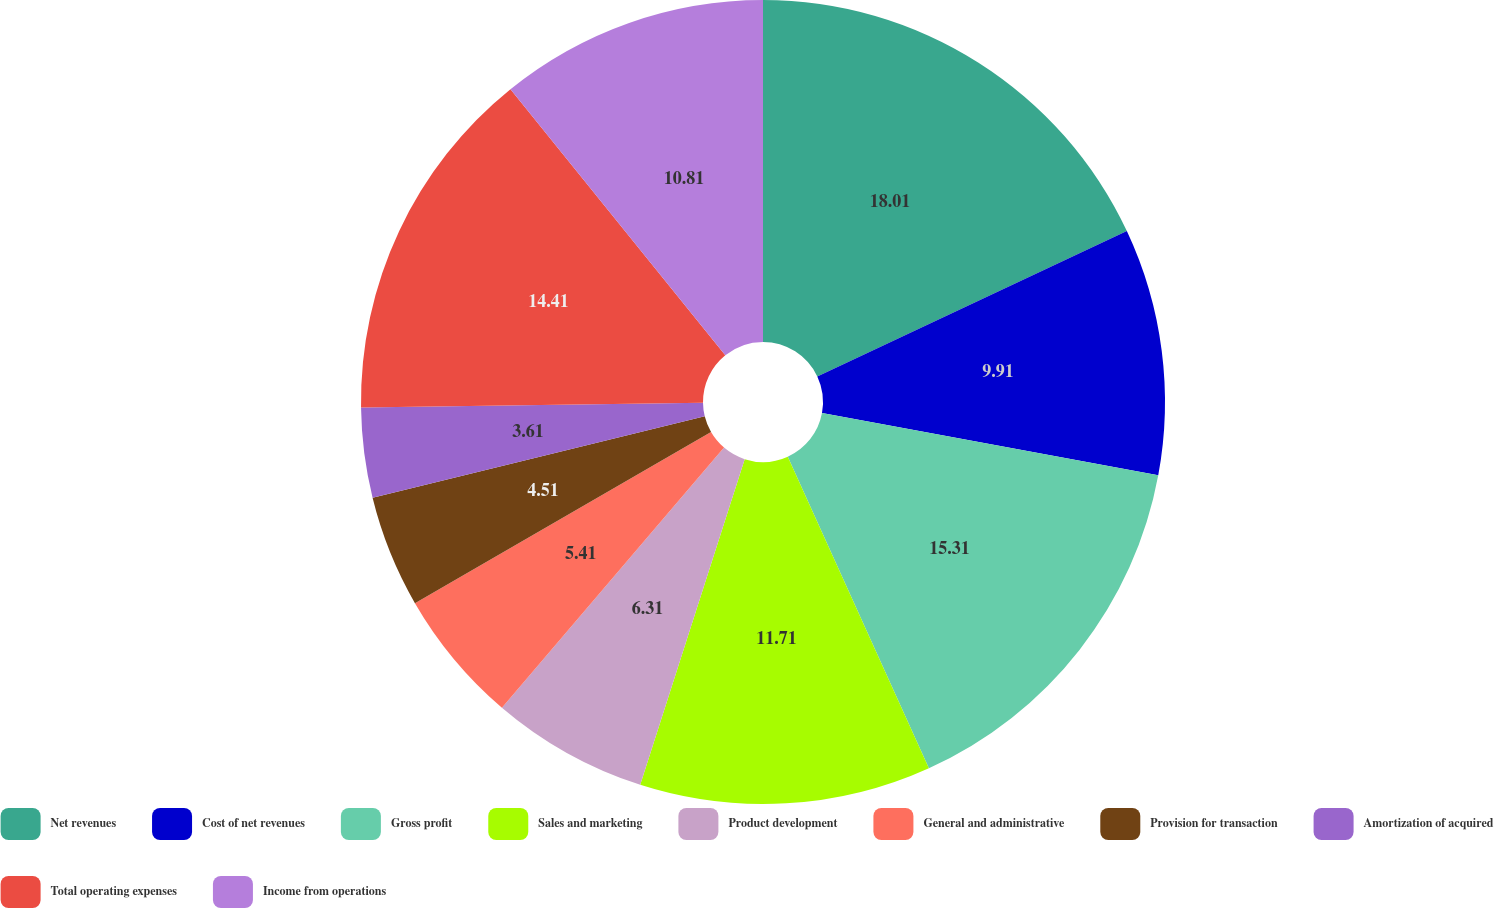Convert chart. <chart><loc_0><loc_0><loc_500><loc_500><pie_chart><fcel>Net revenues<fcel>Cost of net revenues<fcel>Gross profit<fcel>Sales and marketing<fcel>Product development<fcel>General and administrative<fcel>Provision for transaction<fcel>Amortization of acquired<fcel>Total operating expenses<fcel>Income from operations<nl><fcel>18.01%<fcel>9.91%<fcel>15.31%<fcel>11.71%<fcel>6.31%<fcel>5.41%<fcel>4.51%<fcel>3.61%<fcel>14.41%<fcel>10.81%<nl></chart> 